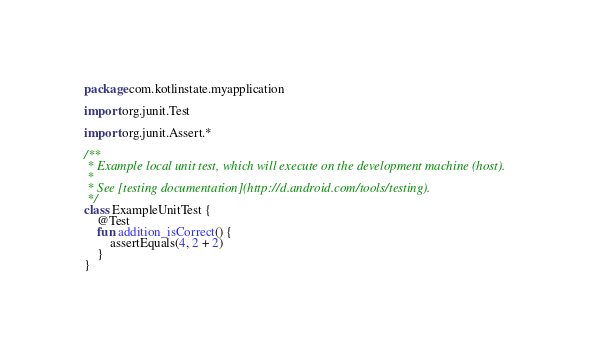<code> <loc_0><loc_0><loc_500><loc_500><_Kotlin_>package com.kotlinstate.myapplication

import org.junit.Test

import org.junit.Assert.*

/**
 * Example local unit test, which will execute on the development machine (host).
 *
 * See [testing documentation](http://d.android.com/tools/testing).
 */
class ExampleUnitTest {
    @Test
    fun addition_isCorrect() {
        assertEquals(4, 2 + 2)
    }
}</code> 